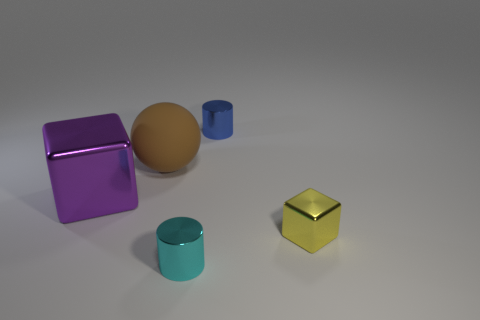Add 4 large red metal spheres. How many objects exist? 9 Subtract all spheres. How many objects are left? 4 Add 2 green rubber objects. How many green rubber objects exist? 2 Subtract 0 green spheres. How many objects are left? 5 Subtract all brown matte cubes. Subtract all large things. How many objects are left? 3 Add 5 big metal things. How many big metal things are left? 6 